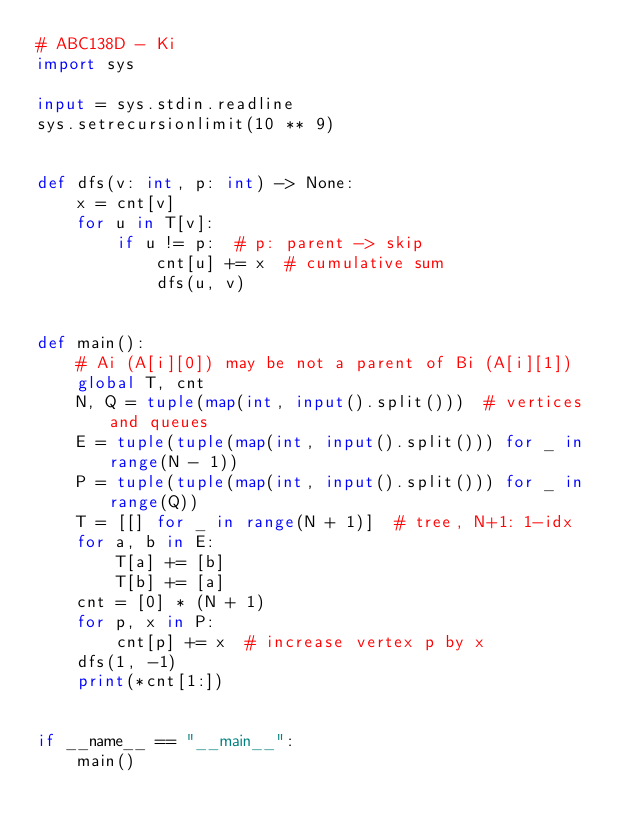Convert code to text. <code><loc_0><loc_0><loc_500><loc_500><_Python_># ABC138D - Ki
import sys

input = sys.stdin.readline
sys.setrecursionlimit(10 ** 9)


def dfs(v: int, p: int) -> None:
    x = cnt[v]
    for u in T[v]:
        if u != p:  # p: parent -> skip
            cnt[u] += x  # cumulative sum
            dfs(u, v)


def main():
    # Ai (A[i][0]) may be not a parent of Bi (A[i][1])
    global T, cnt
    N, Q = tuple(map(int, input().split()))  # vertices and queues
    E = tuple(tuple(map(int, input().split())) for _ in range(N - 1))
    P = tuple(tuple(map(int, input().split())) for _ in range(Q))
    T = [[] for _ in range(N + 1)]  # tree, N+1: 1-idx
    for a, b in E:
        T[a] += [b]
        T[b] += [a]
    cnt = [0] * (N + 1)
    for p, x in P:
        cnt[p] += x  # increase vertex p by x
    dfs(1, -1)
    print(*cnt[1:])


if __name__ == "__main__":
    main()</code> 